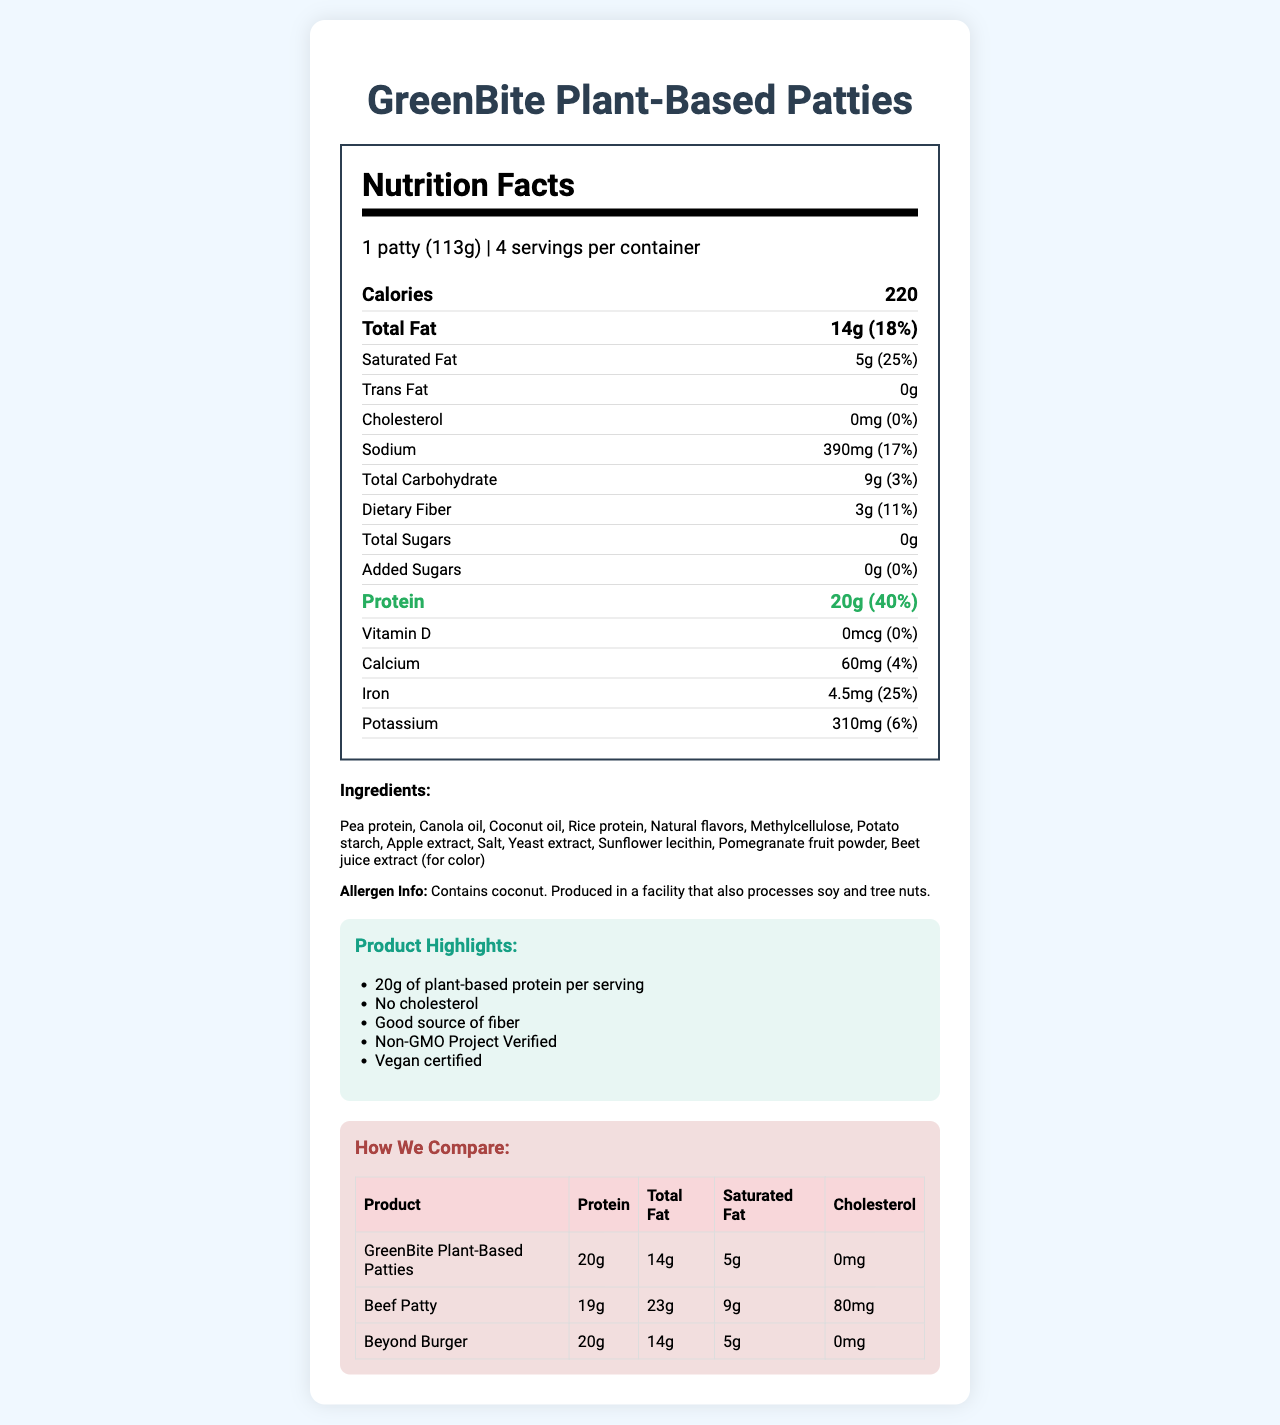what is the serving size? The serving size is stated at the top of the nutrition facts label, under the product name and serving info section.
Answer: 1 patty (113g) how many calories are there per serving? The calories per serving are listed in the big bold text near the top of the nutrition facts label.
Answer: 220 What is the daily value percentage of protein per serving? The daily value percentage of protein is located next to the protein amount in the nutrition facts section.
Answer: 40% What are the saturated fat and total carbohydrate amounts? The amounts for saturated fat and total carbohydrate are listed under their respective nutrient sections in the nutrition facts label.
Answer: 5g saturated fat, 9g total carbohydrate Which ingredient provides the primary protein source? Among the listed ingredients, pea protein is the first ingredient mentioned, indicating it as the primary protein source.
Answer: Pea protein how much iron is in one serving? The iron content in one serving is listed toward the bottom of the nutrition facts section.
Answer: 4.5mg Which of the following marketing claims is highlighted on the product? I. Non-GMO Project Verified II. Contains Soy III. No Cholesterol IV. Good source of fiber The marketing claims section highlights "Non-GMO Project Verified," "No Cholesterol," and "Good source of fiber."
Answer: I, III, IV Which competitor product has more cholesterol than GreenBite Plant-Based Patties? A. Beef Patty B. Beyond Burger C. Both The competitor comparison table shows that the Beef Patty has 80mg of cholesterol, while the Beyond Burger has 0mg, same as GreenBite.
Answer: A Is GreenBite Plant-Based Patties a good source of fiber? The product is described as a good source of fiber in the marketing claims section.
Answer: Yes Summarize the main nutritional advantages of GreenBite Plant-Based Patties. The main advantages are highlighted in the product's marketing claims and nutrition facts, emphasizing high protein content, no cholesterol, good fiber, and compliance with various certifications.
Answer: Contains 20g of plant-based protein per serving, no cholesterol, good source of fiber, low saturated fat, Non-GMO, and vegan certified. what is the manufacturing facility's process for ensuring allergen safety? The document mentions the allergen info but does not provide details on the allergen safety processes used in the manufacturing facility.
Answer: Not enough information 